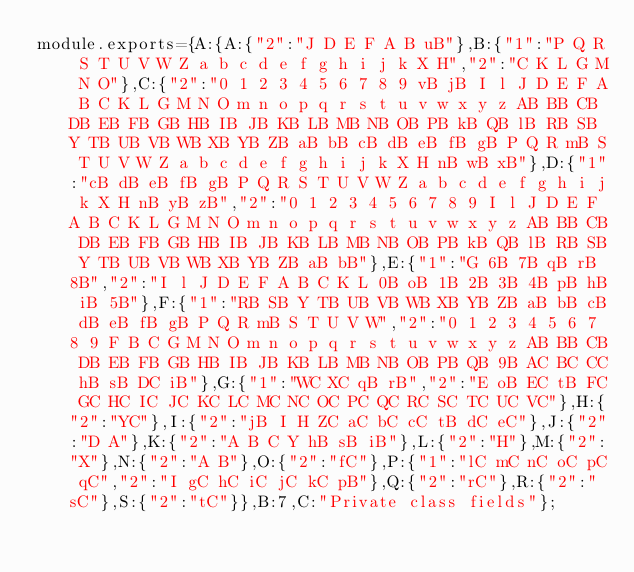<code> <loc_0><loc_0><loc_500><loc_500><_JavaScript_>module.exports={A:{A:{"2":"J D E F A B uB"},B:{"1":"P Q R S T U V W Z a b c d e f g h i j k X H","2":"C K L G M N O"},C:{"2":"0 1 2 3 4 5 6 7 8 9 vB jB I l J D E F A B C K L G M N O m n o p q r s t u v w x y z AB BB CB DB EB FB GB HB IB JB KB LB MB NB OB PB kB QB lB RB SB Y TB UB VB WB XB YB ZB aB bB cB dB eB fB gB P Q R mB S T U V W Z a b c d e f g h i j k X H nB wB xB"},D:{"1":"cB dB eB fB gB P Q R S T U V W Z a b c d e f g h i j k X H nB yB zB","2":"0 1 2 3 4 5 6 7 8 9 I l J D E F A B C K L G M N O m n o p q r s t u v w x y z AB BB CB DB EB FB GB HB IB JB KB LB MB NB OB PB kB QB lB RB SB Y TB UB VB WB XB YB ZB aB bB"},E:{"1":"G 6B 7B qB rB 8B","2":"I l J D E F A B C K L 0B oB 1B 2B 3B 4B pB hB iB 5B"},F:{"1":"RB SB Y TB UB VB WB XB YB ZB aB bB cB dB eB fB gB P Q R mB S T U V W","2":"0 1 2 3 4 5 6 7 8 9 F B C G M N O m n o p q r s t u v w x y z AB BB CB DB EB FB GB HB IB JB KB LB MB NB OB PB QB 9B AC BC CC hB sB DC iB"},G:{"1":"WC XC qB rB","2":"E oB EC tB FC GC HC IC JC KC LC MC NC OC PC QC RC SC TC UC VC"},H:{"2":"YC"},I:{"2":"jB I H ZC aC bC cC tB dC eC"},J:{"2":"D A"},K:{"2":"A B C Y hB sB iB"},L:{"2":"H"},M:{"2":"X"},N:{"2":"A B"},O:{"2":"fC"},P:{"1":"lC mC nC oC pC qC","2":"I gC hC iC jC kC pB"},Q:{"2":"rC"},R:{"2":"sC"},S:{"2":"tC"}},B:7,C:"Private class fields"};
</code> 